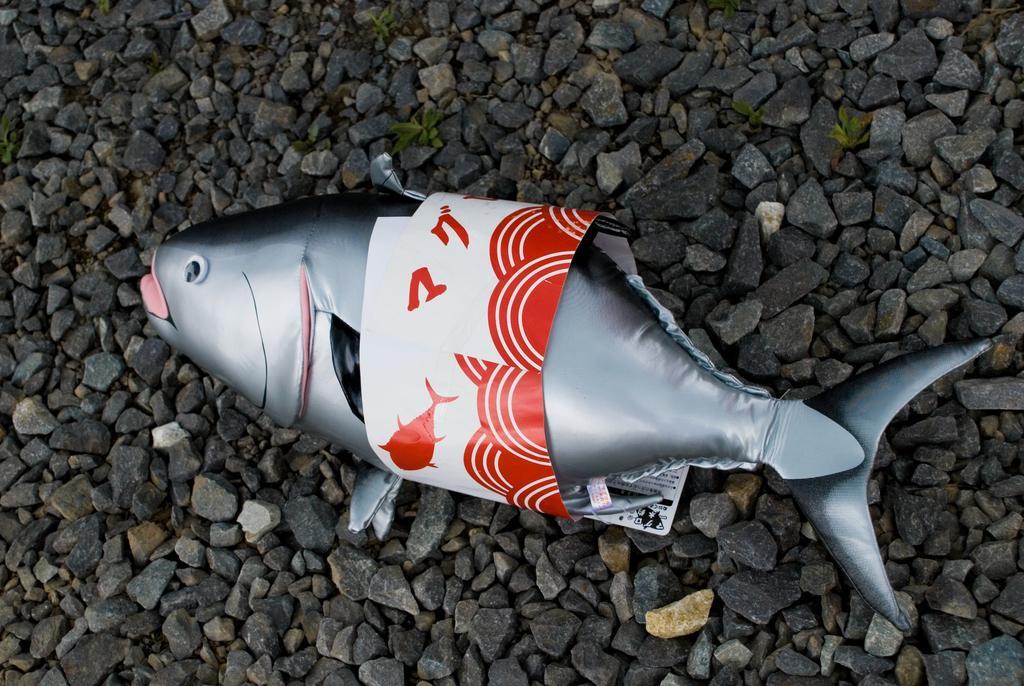Could you give a brief overview of what you see in this image? In this image there is a fish balloon is on few rocks having plants. 